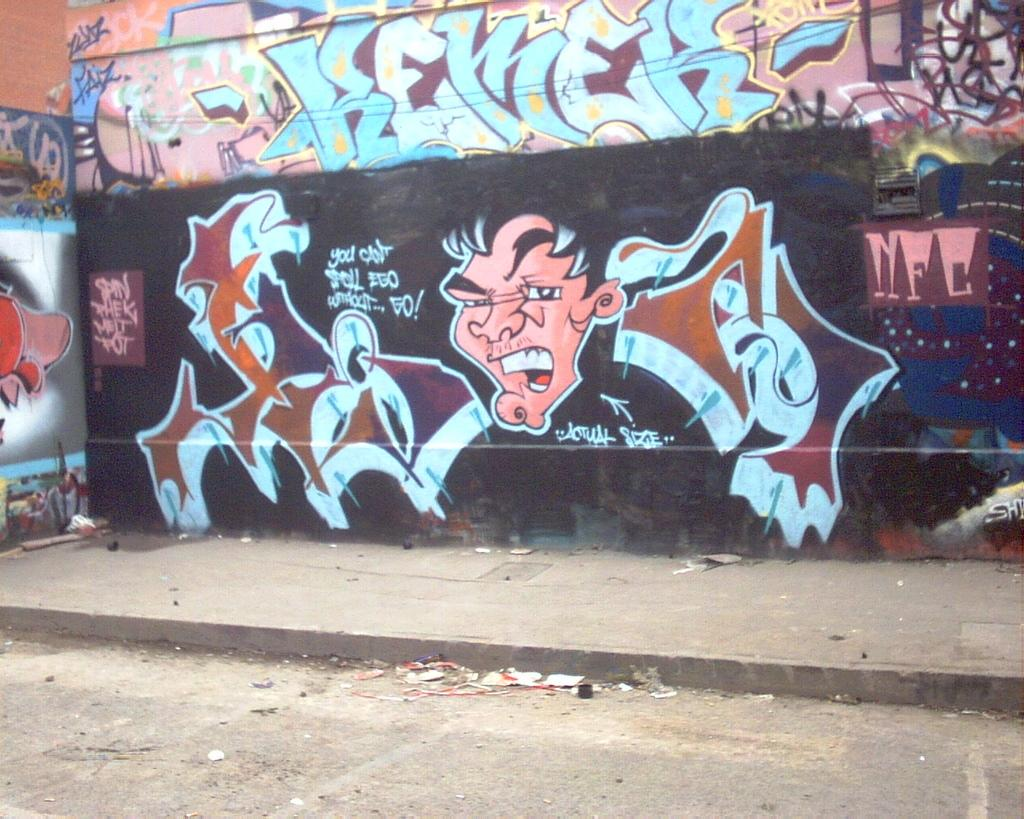What is depicted on the wall in the image? There is graffiti of a person in the image. What else can be seen on the wall besides the graffiti? There is text on the wall in the image. What type of bun is being used to hold the graffiti artist's hair in the image? There is no graffiti artist or bun present in the image; it only features graffiti of a person and text on the wall. 